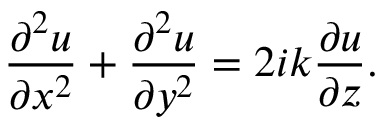<formula> <loc_0><loc_0><loc_500><loc_500>{ \frac { \partial ^ { 2 } u } { \partial x ^ { 2 } } } + { \frac { \partial ^ { 2 } u } { \partial y ^ { 2 } } } = 2 i k { \frac { \partial u } { \partial z } } .</formula> 